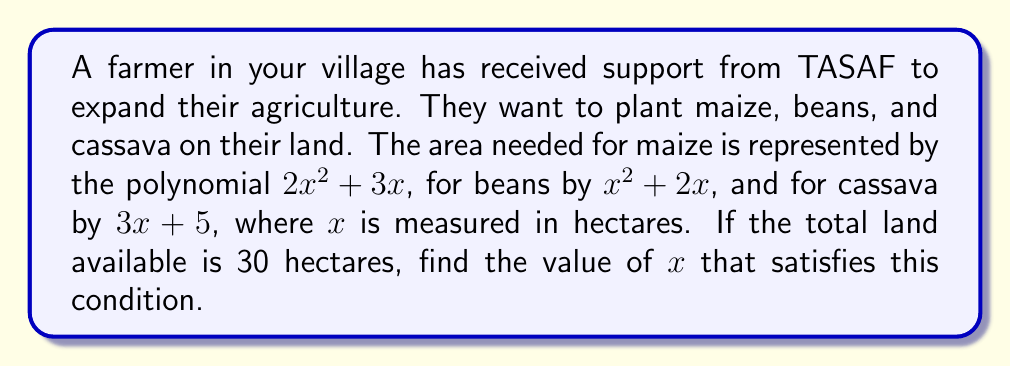Show me your answer to this math problem. To solve this problem, we need to follow these steps:

1. Add the polynomials representing the area for each crop:
   Maize: $2x^2 + 3x$
   Beans: $x^2 + 2x$
   Cassava: $3x + 5$
   
   Total: $(2x^2 + 3x) + (x^2 + 2x) + (3x + 5)$

2. Simplify the resulting polynomial:
   $2x^2 + 3x + x^2 + 2x + 3x + 5$
   $= 3x^2 + 8x + 5$

3. Set this polynomial equal to the total available land (30 hectares):
   $3x^2 + 8x + 5 = 30$

4. Rearrange the equation to standard form:
   $3x^2 + 8x - 25 = 0$

5. Solve this quadratic equation using the quadratic formula:
   $x = \frac{-b \pm \sqrt{b^2 - 4ac}}{2a}$
   
   Where $a = 3$, $b = 8$, and $c = -25$

6. Substitute these values into the quadratic formula:
   $x = \frac{-8 \pm \sqrt{8^2 - 4(3)(-25)}}{2(3)}$
   $= \frac{-8 \pm \sqrt{64 + 300}}{6}$
   $= \frac{-8 \pm \sqrt{364}}{6}$
   $= \frac{-8 \pm 19.08}{6}$

7. This gives us two solutions:
   $x = \frac{-8 + 19.08}{6} \approx 1.85$ or $x = \frac{-8 - 19.08}{6} \approx -4.51$

8. Since land area cannot be negative, we discard the negative solution.
Answer: The value of $x$ that satisfies the condition is approximately 1.85 hectares. 